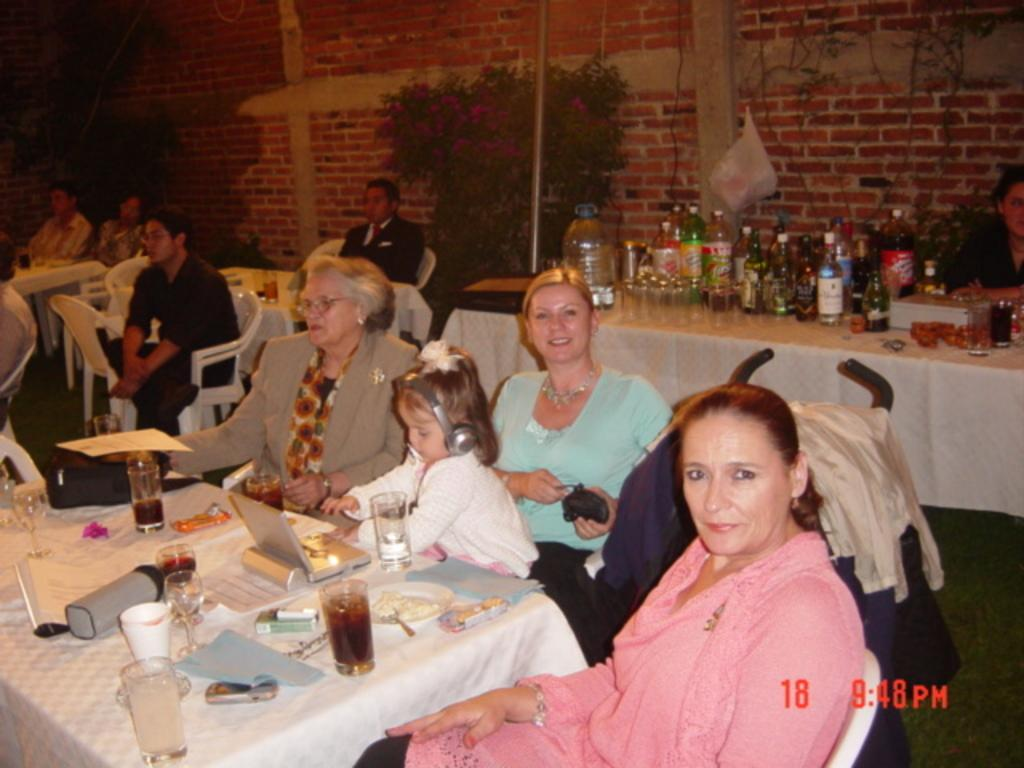What are the people in the image doing? People are sitting on chairs near a table in the image. What can be seen on the table? There is a glass and a paper on the table. What is visible in the background? There is a plant, a wall, and another table in the background. What is on the second table in the background? Bottles are present on the second table. How many visitors are present in the image? There is no mention of visitors in the image; it only shows people sitting on chairs near a table. What type of jeans are the people wearing in the image? There is no information about the clothing of the people in the image, so we cannot determine if they are wearing jeans or any other type of clothing. 